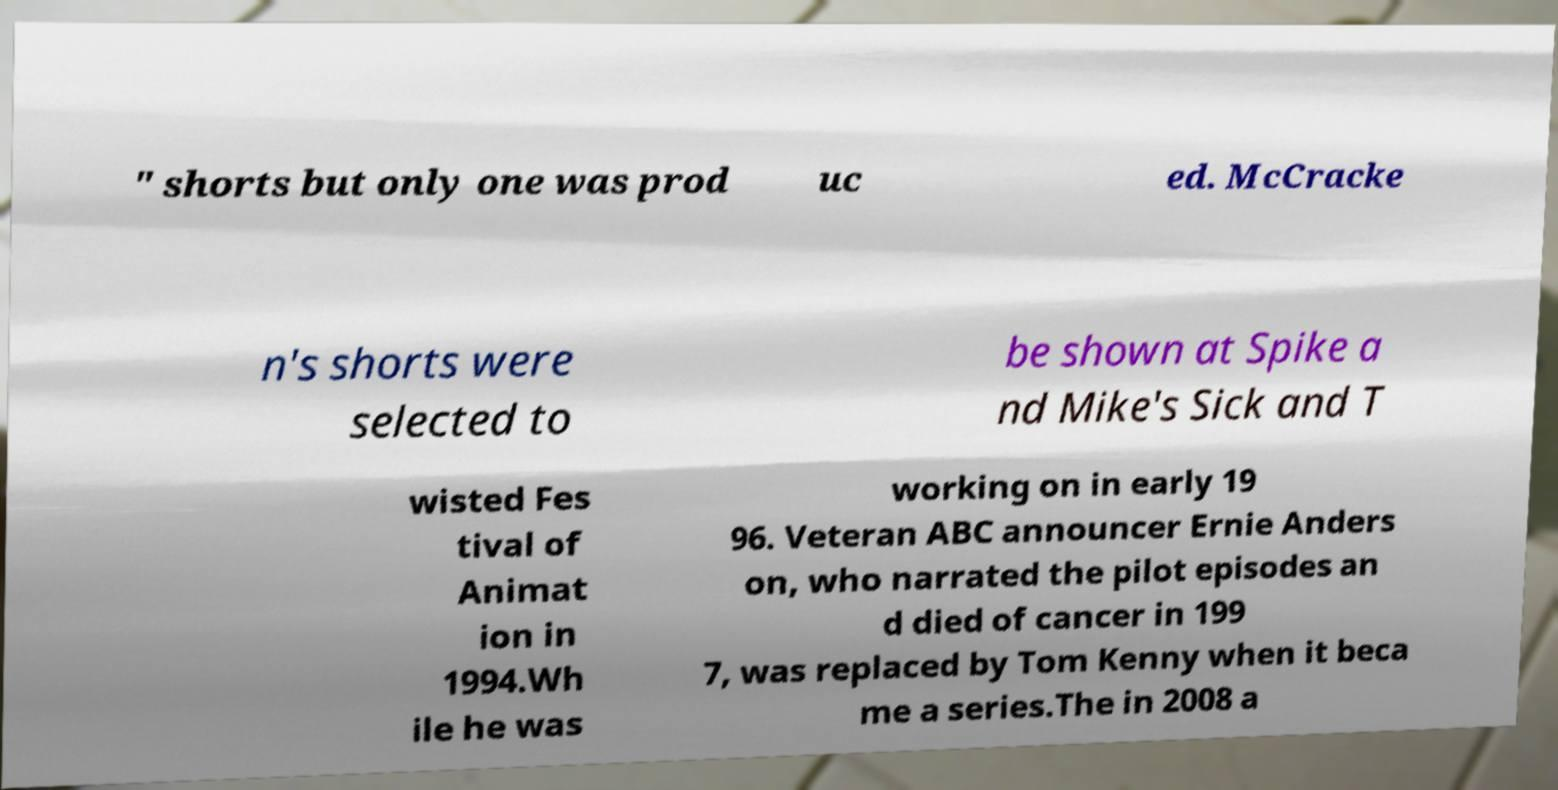For documentation purposes, I need the text within this image transcribed. Could you provide that? " shorts but only one was prod uc ed. McCracke n's shorts were selected to be shown at Spike a nd Mike's Sick and T wisted Fes tival of Animat ion in 1994.Wh ile he was working on in early 19 96. Veteran ABC announcer Ernie Anders on, who narrated the pilot episodes an d died of cancer in 199 7, was replaced by Tom Kenny when it beca me a series.The in 2008 a 